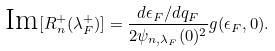Convert formula to latex. <formula><loc_0><loc_0><loc_500><loc_500>\text {Im} [ R _ { n } ^ { + } ( \lambda _ { F } ^ { + } ) ] = \frac { d \epsilon _ { F } / d q _ { F } } { 2 \psi _ { n , \lambda _ { F } } ( 0 ) ^ { 2 } } g ( \epsilon _ { F } , 0 ) .</formula> 